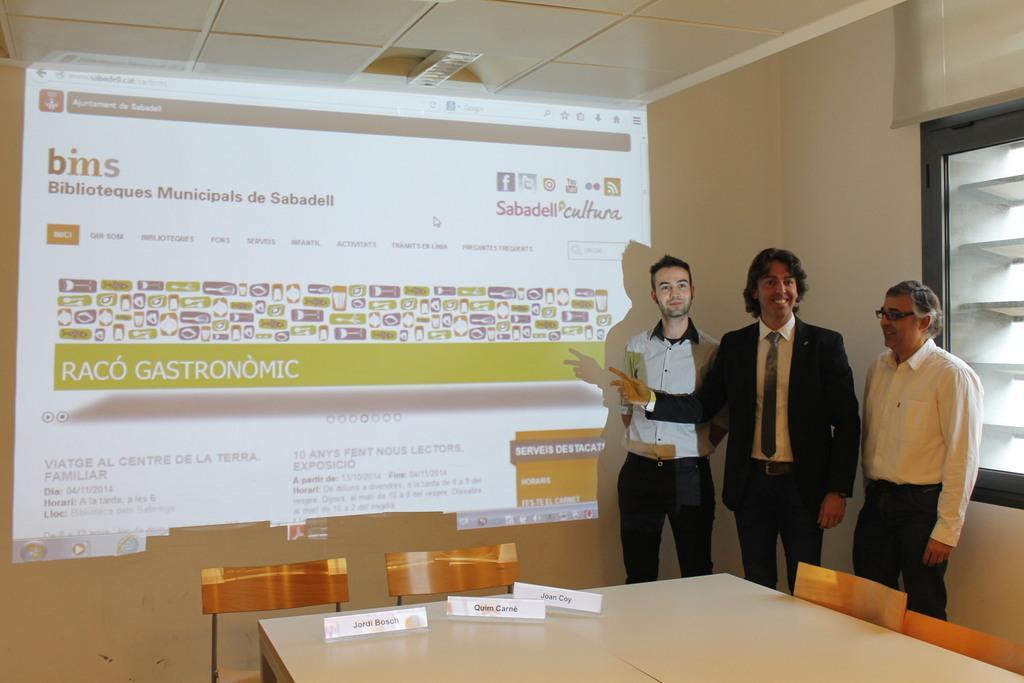Describe this image in one or two sentences. In this picture we can see three persons standing on the floor. This is table and these are the chairs. On the background we can see a screen. And this is the wall. 